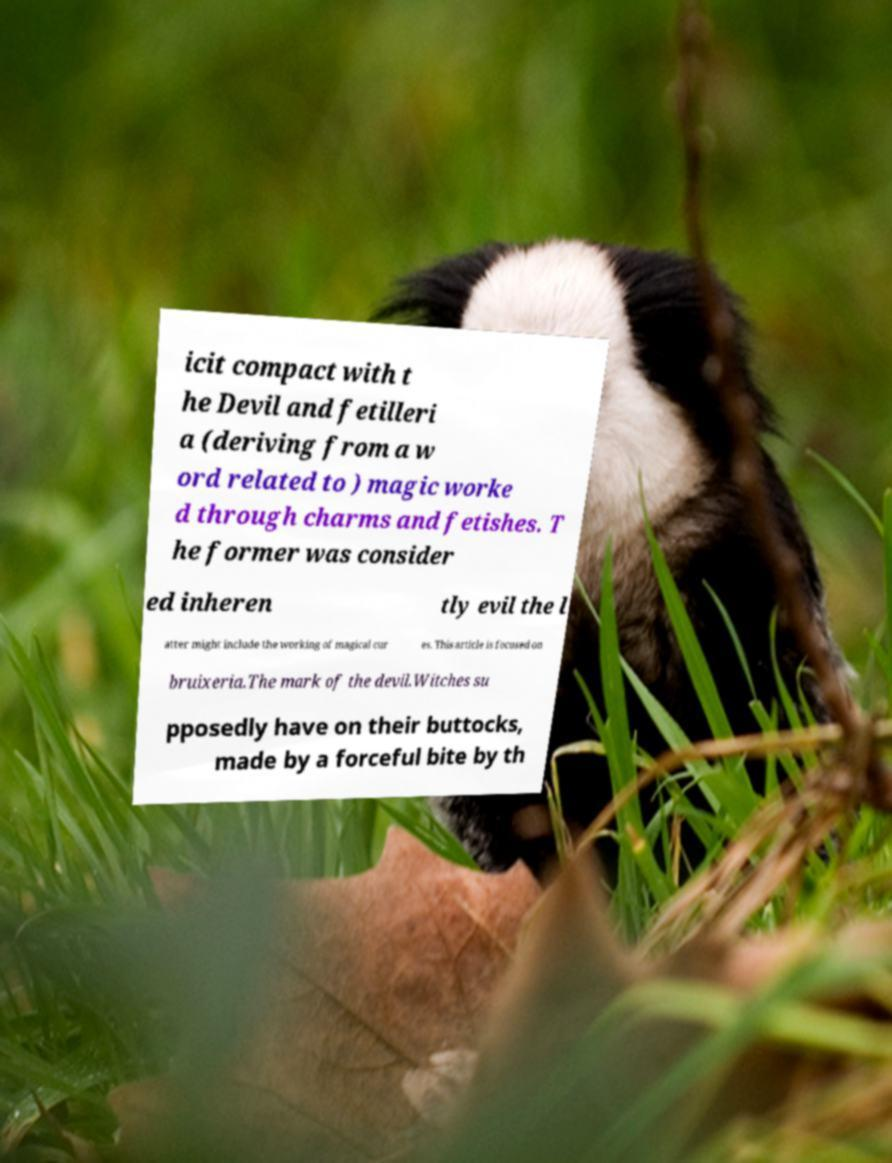Could you assist in decoding the text presented in this image and type it out clearly? icit compact with t he Devil and fetilleri a (deriving from a w ord related to ) magic worke d through charms and fetishes. T he former was consider ed inheren tly evil the l atter might include the working of magical cur es. This article is focused on bruixeria.The mark of the devil.Witches su pposedly have on their buttocks, made by a forceful bite by th 